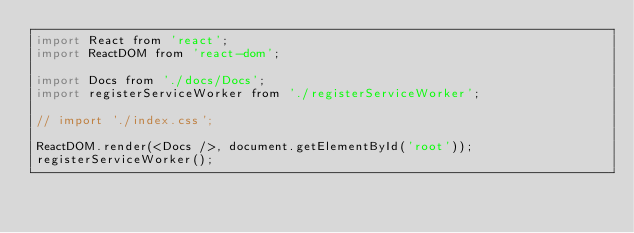Convert code to text. <code><loc_0><loc_0><loc_500><loc_500><_JavaScript_>import React from 'react';
import ReactDOM from 'react-dom';

import Docs from './docs/Docs';
import registerServiceWorker from './registerServiceWorker';

// import './index.css';

ReactDOM.render(<Docs />, document.getElementById('root'));
registerServiceWorker();
</code> 